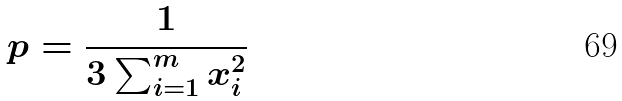<formula> <loc_0><loc_0><loc_500><loc_500>p = \frac { 1 } { 3 \sum _ { i = 1 } ^ { m } x _ { i } ^ { 2 } }</formula> 